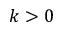<formula> <loc_0><loc_0><loc_500><loc_500>k > 0</formula> 